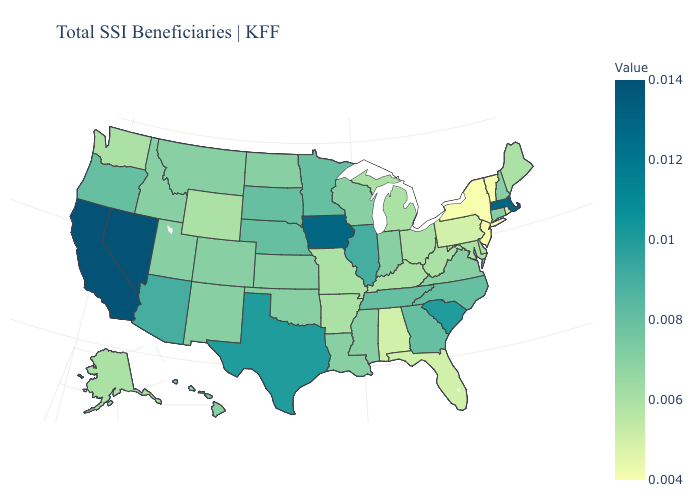Does New York have the lowest value in the Northeast?
Give a very brief answer. Yes. Does Arizona have the lowest value in the West?
Quick response, please. No. Does New Mexico have the lowest value in the West?
Concise answer only. No. Does South Carolina have the highest value in the South?
Keep it brief. Yes. Does South Dakota have the highest value in the USA?
Concise answer only. No. 